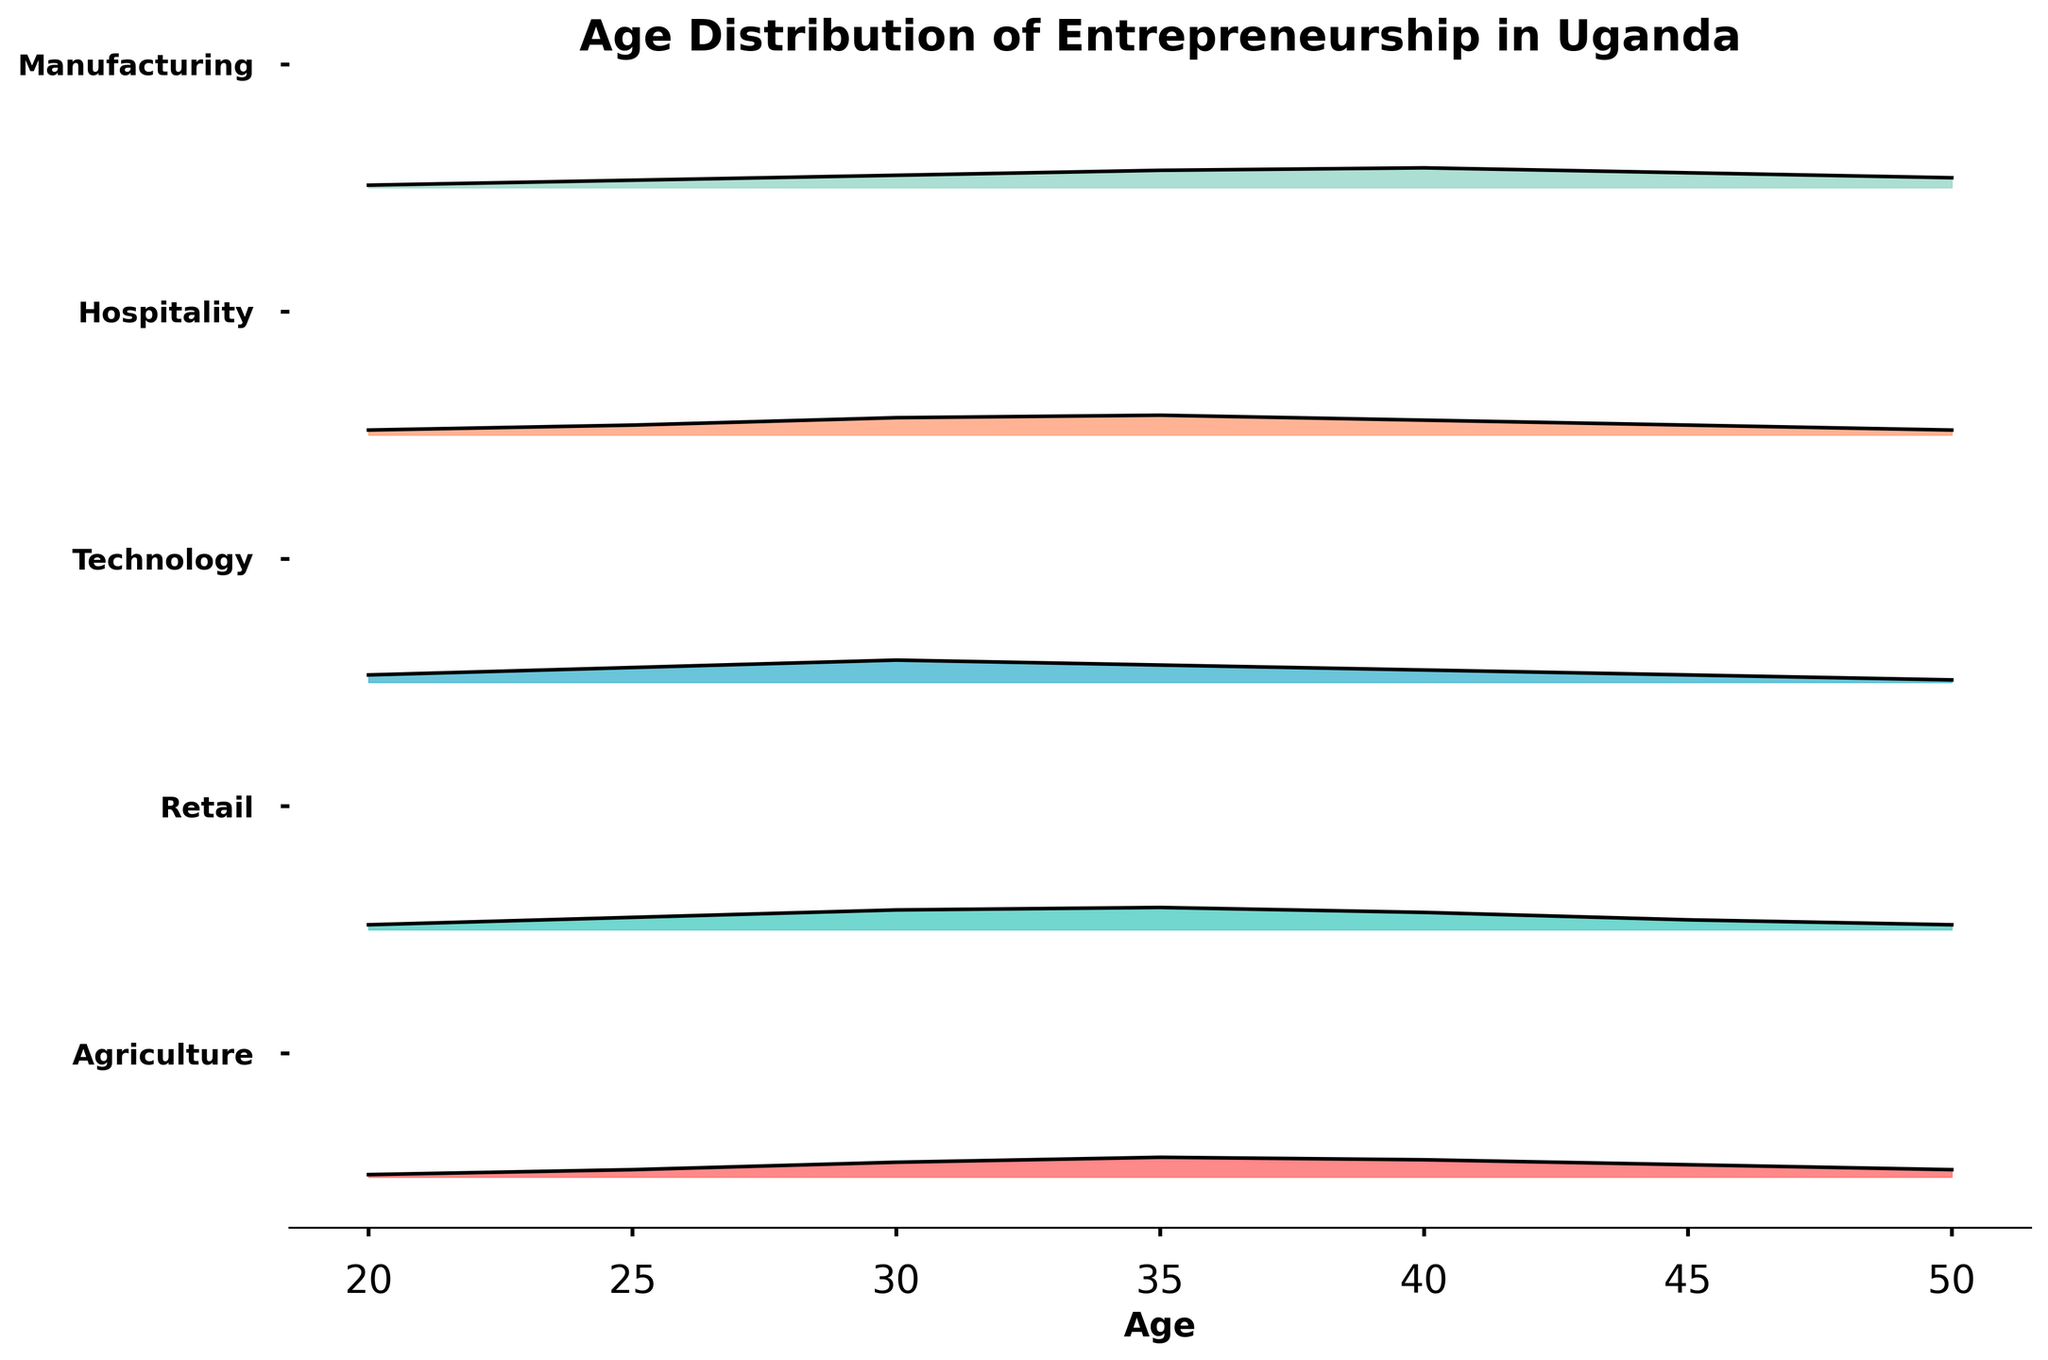How many industries are represented in the plot? There are five distinct areas in the Ridgeline plot, each representing a different industry.
Answer: 5 What industry is represented by the highest peak density in the 35 age group? Look for the highest density at the age 35 across the different colors, which corresponds to the Retail industry.
Answer: Retail Which industry has the widest age distribution? The width of the age distribution can be assessed by the range of ages over which the density is non-zero. The Agriculture industry covers the widest range from 20 to 50.
Answer: Agriculture In which age group does the Technology industry have its maximum density? Examine the peaks within the area corresponding to the Technology industry. The highest peak occurs at age 30.
Answer: 30 Compare the peak densities between Agriculture and Manufacturing in the 40 age group. Which is higher? Examine the density values at age 40 for both Agriculture and Manufacturing. Agriculture has a density of 0.07, while Manufacturing has 0.08.
Answer: Manufacturing What observed trend can be made about entrepreneurs' ages in the Hospitality industry? Look at the overall shape and height of the curve for Hospitality. The peak density is at age 35, and it indicates that most entrepreneurs are around this age, with fewer younger and older entrepreneurs.
Answer: Peak at age 35, indicating many entrepreneurs are around this age Which industry shows the least density at age 20? Identify the area with the smallest density at the starting age of 20. The Manufacturing industry density at age 20 is 0.01.
Answer: Manufacturing How does the shape of the Retail density curve compare to the Technology density curve? Both Retail and Technology have peaks at age 30, but the Technology curve rises more sharply and is wider at younger ages, indicating a younger entrepreneurial trend.
Answer: Both peak at age 30, Technology rises more sharply and is wider at younger ages What is the age range with the highest density for both Agriculture and Hospitality industries? Compare the highest points on both curves within the age range 20 to 50. Agriculture peaks around 35-40, Hospitality peaks between 30-35.
Answer: Agriculture: 35-40, Hospitality: 30-35 In which age group do we see a similar density in both Retail and Technology industries? Identify the age group where the densities of both Retail and Technology are close. Retail and Technology have similar densities around age 35.
Answer: Age 35 